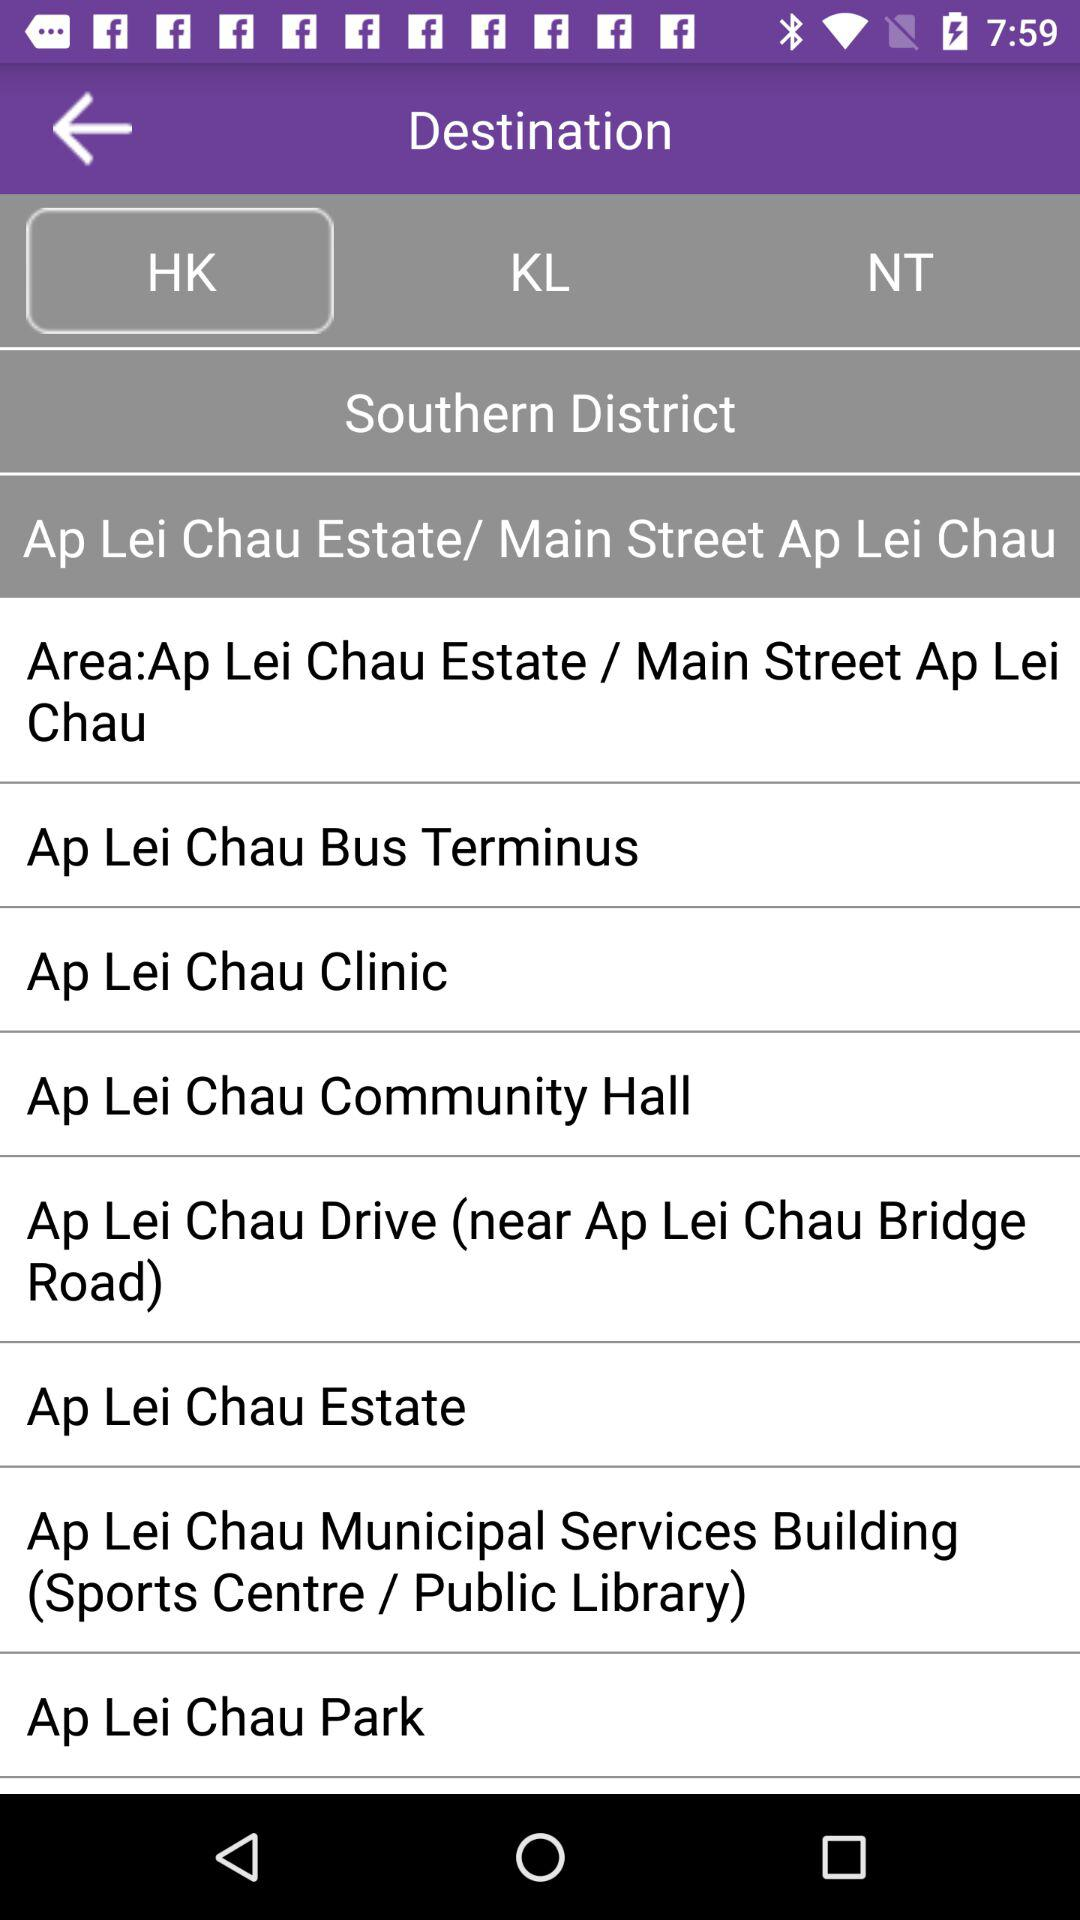What is the selected area? The selected area is Ap Lei Chau Estate or Main Street Ap Lei Chau. 